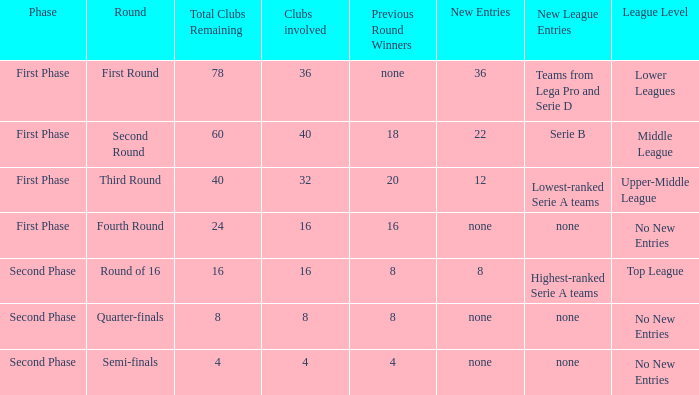During the first part of the phase with 16 clubs, who were the victorious teams from the last round? 16.0. 